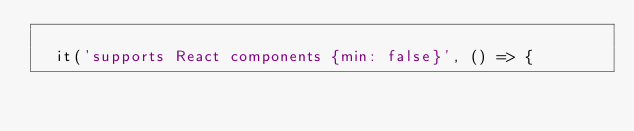<code> <loc_0><loc_0><loc_500><loc_500><_JavaScript_>
  it('supports React components {min: false}', () => {</code> 